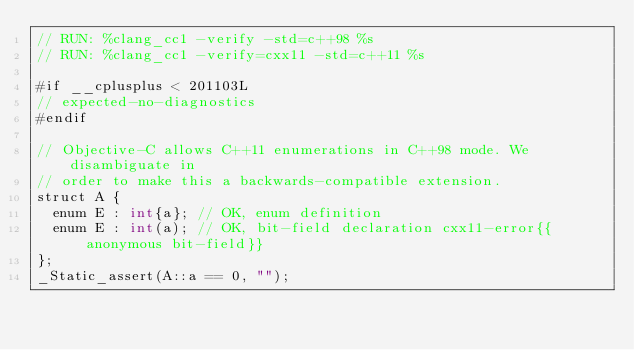Convert code to text. <code><loc_0><loc_0><loc_500><loc_500><_ObjectiveC_>// RUN: %clang_cc1 -verify -std=c++98 %s
// RUN: %clang_cc1 -verify=cxx11 -std=c++11 %s

#if __cplusplus < 201103L
// expected-no-diagnostics
#endif

// Objective-C allows C++11 enumerations in C++98 mode. We disambiguate in
// order to make this a backwards-compatible extension.
struct A {
  enum E : int{a}; // OK, enum definition
  enum E : int(a); // OK, bit-field declaration cxx11-error{{anonymous bit-field}}
};
_Static_assert(A::a == 0, "");
</code> 